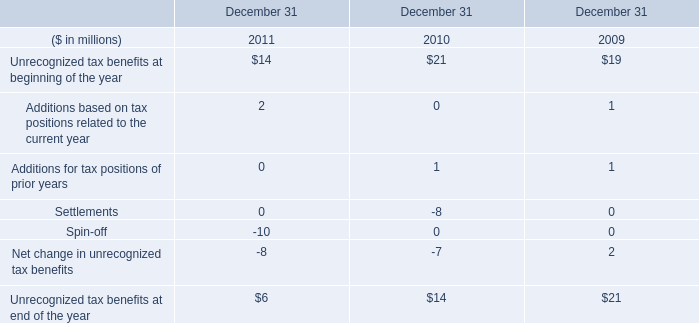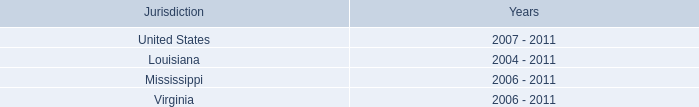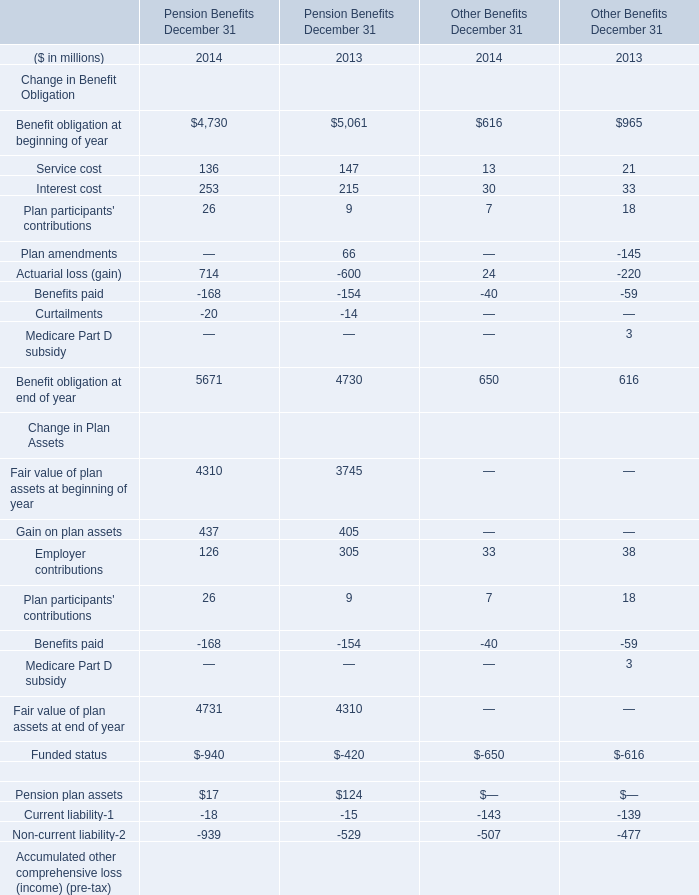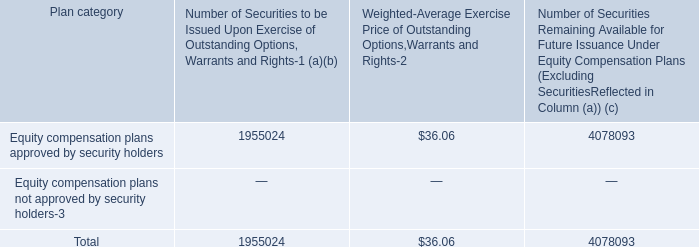what portion of equity compensation plan remains available for future issuance? 
Computations: (4078093 / (1955024 + 4078093))
Answer: 0.67595. What was the average of the Fair value of plan assets at beginning of year in the years where Gain on plan assets is positive? (in million) 
Computations: ((4310 + 3745) / 2)
Answer: 4027.5. 